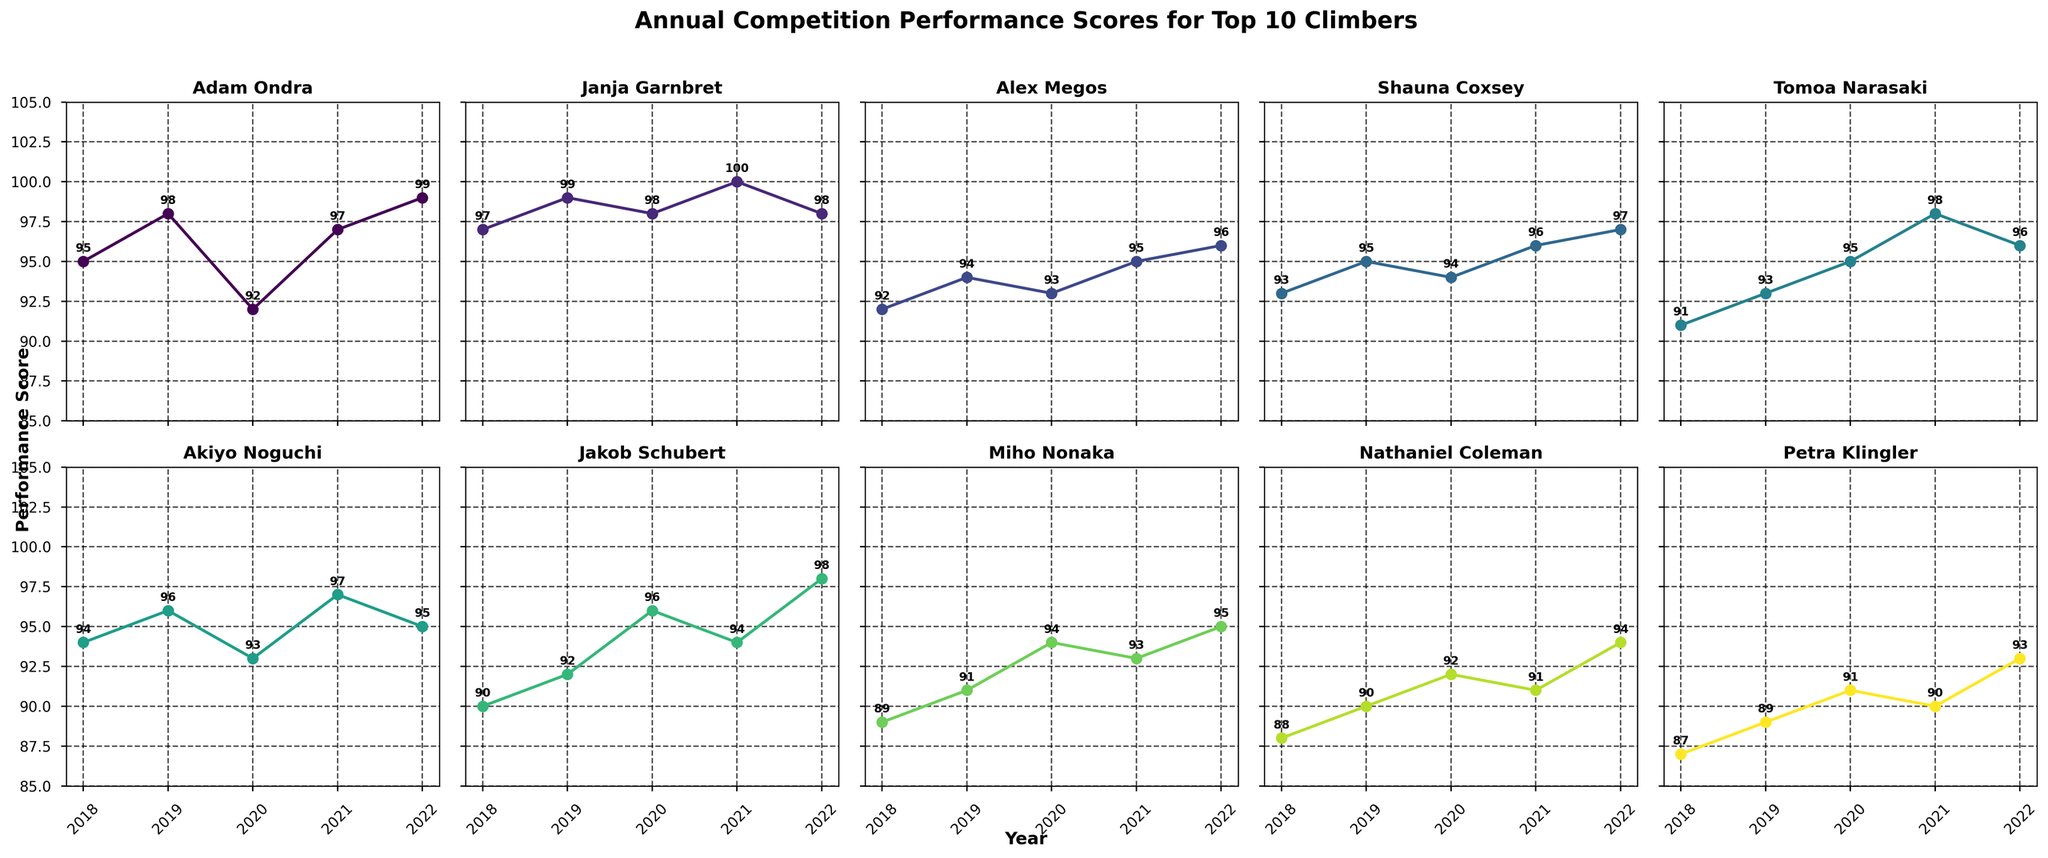What is the average performance score of Adam Ondra over the five years? To find the average, sum Adam Ondra's scores (95 + 98 + 92 + 97 + 99) and then divide by 5. This calculation is (95 + 98 + 92 + 97 + 99) / 5 = 481 / 5 = 96.2.
Answer: 96.2 Who had the highest performance score in 2021? Look at the subplot for each climber and identify the climber with the highest score in 2021. Janja Garnbret has a 100 in 2021, which is the highest score for that year.
Answer: Janja Garnbret In which year did Alex Megos have his highest score, and what was the score? Alex Megos scored the highest in 2022 with a score of 96, as identified in his subplot.
Answer: 2022, 96 Compare the performance scores of Tomoa Narasaki and Miho Nonaka in 2019. Who performed better? Tomoa Narasaki's score in 2019 is 93, while Miho Nonaka's score in 2019 is 91, so Tomoa Narasaki performed better.
Answer: Tomoa Narasaki Which climber showed the most significant improvement from 2020 to 2021? Compare the difference between the 2020 and 2021 scores for all climbers. The climber with the greatest positive difference in scores is the one that improved the most. Adam Ondra improved from 92 to 97, which is an improvement of 5 points – the highest among all climbers.
Answer: Adam Ondra What is the trend of performance scores for Shauna Coxsey from 2018 to 2022? Observe Shauna Coxsey's subplot and note the scores from each year. Her scores are 93, 95, 94, 96, and 97, which indicate a generally increasing trend over the years.
Answer: Increasing trend How many climbers had a performance score of 98 or above in 2022? Check each subplot's score for the year 2022 and count the climbers with scores of 98 or higher. Adam Ondra, Janja Garnbret, and Jakob Schubert each have a score of 98 or higher in 2022, so the count is 3.
Answer: 3 Did any climber maintain a perfectly consistent performance score during these five years? Consistency means having the same score each year. Review each subplot to see if any climber’s scores are identical over the years. None of the climbers have the same score throughout all five years.
Answer: No Between Akiyo Noguchi and Nathaniel Coleman, who showed a more stable performance (less variation) over the years? Calculate the range (difference between the highest and lowest scores) for each climber. Akiyo Noguchi’s scores range from 93 to 97 (range = 4), while Nathaniel Coleman’s scores range from 88 to 94 (range = 6). Akiyo Noguchi has a smaller range, indicating more stability.
Answer: Akiyo Noguchi Who showed a declining performance trend from 2018 to 2022? Determine if any climber's scores consistently decreased over the five years. Petra Klingler has a score trend of 87, 89, 91, 90, 93 which is not consistently declining. Nathaniel Coleman showed some years with declining performance, but not consistently. None showed a continuously declining trend in the provided years.
Answer: None 